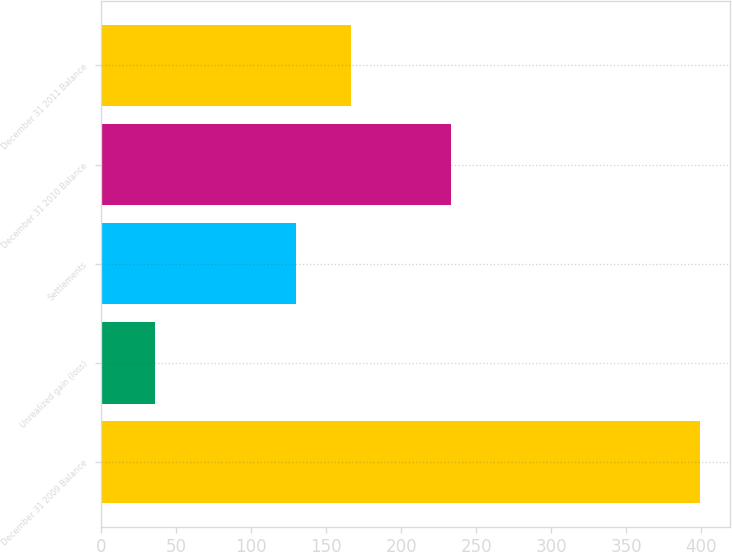Convert chart to OTSL. <chart><loc_0><loc_0><loc_500><loc_500><bar_chart><fcel>December 31 2009 Balance<fcel>Unrealized gain (loss)<fcel>Settlements<fcel>December 31 2010 Balance<fcel>December 31 2011 Balance<nl><fcel>399<fcel>36<fcel>130<fcel>233<fcel>166.3<nl></chart> 